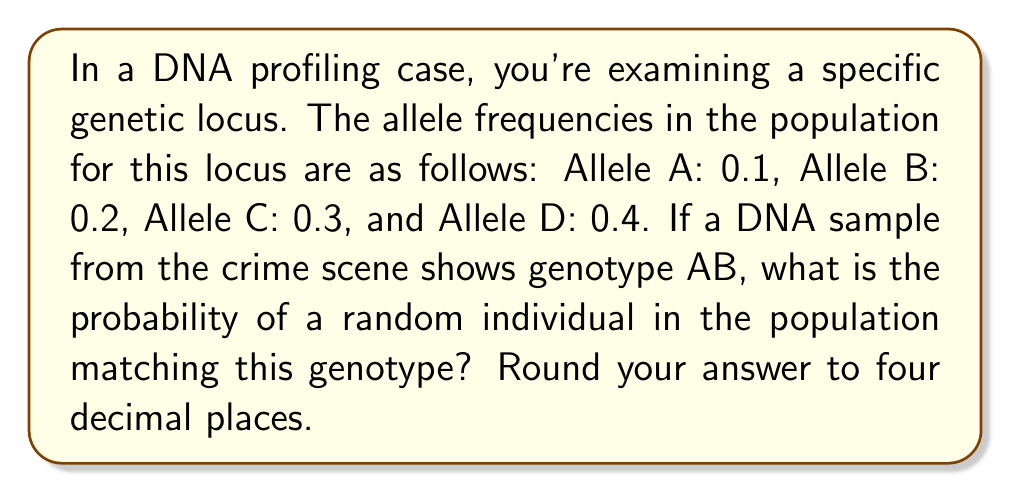Provide a solution to this math problem. To solve this problem, we need to follow these steps:

1) The genotype AB consists of two different alleles. The order doesn't matter (AB is the same as BA), so we need to calculate the probability of getting A and B in any order.

2) The probability of getting allele A is 0.1, and the probability of getting allele B is 0.2.

3) For a diploid organism (which humans are), we need to consider two independent events:
   - Getting A from one parent and B from the other
   - Getting B from one parent and A from the other

4) The probability of getting A from one parent and B from the other is:
   $P(A) \times P(B) = 0.1 \times 0.2 = 0.02$

5) Since the order doesn't matter, we need to double this probability to account for both AB and BA:
   $2 \times P(A) \times P(B) = 2 \times 0.02 = 0.04$

6) Therefore, the probability of a random individual in the population having the AB genotype is 0.04 or 4%.

7) Rounding to four decimal places: 0.0400

This calculation assumes Hardy-Weinberg equilibrium and that the alleles are inherited independently.
Answer: 0.0400 